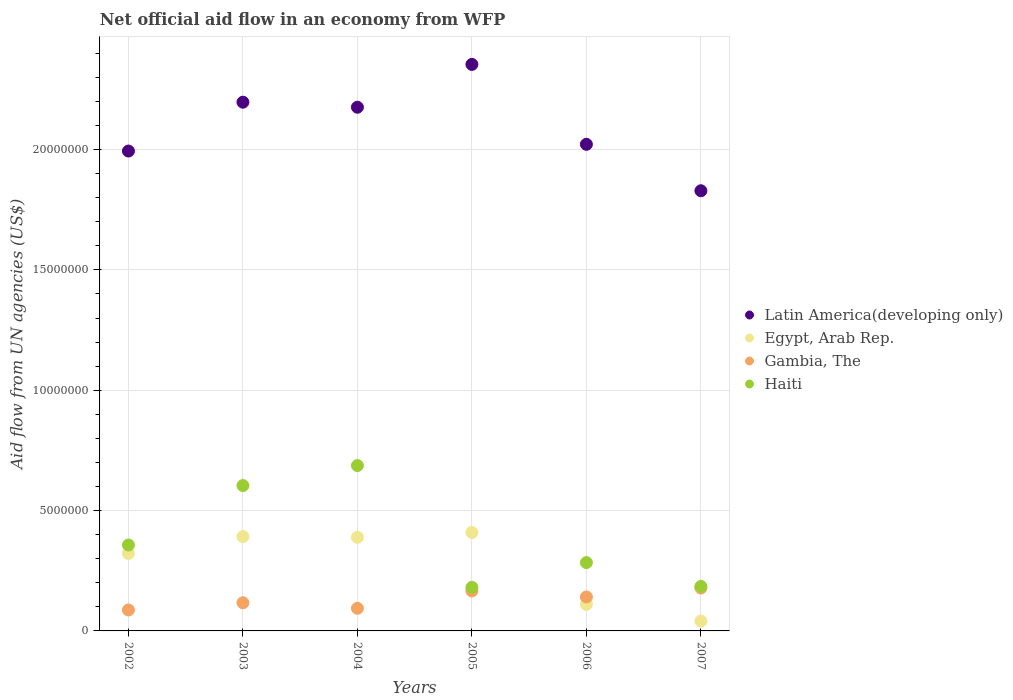How many different coloured dotlines are there?
Give a very brief answer. 4. What is the net official aid flow in Egypt, Arab Rep. in 2007?
Your answer should be compact. 4.10e+05. Across all years, what is the maximum net official aid flow in Gambia, The?
Offer a terse response. 1.78e+06. Across all years, what is the minimum net official aid flow in Egypt, Arab Rep.?
Your response must be concise. 4.10e+05. In which year was the net official aid flow in Latin America(developing only) maximum?
Provide a succinct answer. 2005. What is the total net official aid flow in Latin America(developing only) in the graph?
Your response must be concise. 1.26e+08. What is the difference between the net official aid flow in Egypt, Arab Rep. in 2002 and that in 2004?
Give a very brief answer. -6.70e+05. What is the difference between the net official aid flow in Latin America(developing only) in 2006 and the net official aid flow in Egypt, Arab Rep. in 2005?
Offer a terse response. 1.61e+07. What is the average net official aid flow in Latin America(developing only) per year?
Ensure brevity in your answer.  2.10e+07. In the year 2003, what is the difference between the net official aid flow in Egypt, Arab Rep. and net official aid flow in Latin America(developing only)?
Make the answer very short. -1.80e+07. What is the ratio of the net official aid flow in Haiti in 2003 to that in 2005?
Give a very brief answer. 3.34. Is the net official aid flow in Egypt, Arab Rep. in 2003 less than that in 2004?
Keep it short and to the point. No. Is the difference between the net official aid flow in Egypt, Arab Rep. in 2004 and 2007 greater than the difference between the net official aid flow in Latin America(developing only) in 2004 and 2007?
Your response must be concise. Yes. What is the difference between the highest and the second highest net official aid flow in Latin America(developing only)?
Offer a terse response. 1.57e+06. What is the difference between the highest and the lowest net official aid flow in Gambia, The?
Your answer should be compact. 9.10e+05. Is it the case that in every year, the sum of the net official aid flow in Gambia, The and net official aid flow in Egypt, Arab Rep.  is greater than the net official aid flow in Latin America(developing only)?
Offer a terse response. No. Is the net official aid flow in Egypt, Arab Rep. strictly greater than the net official aid flow in Latin America(developing only) over the years?
Give a very brief answer. No. How many dotlines are there?
Your answer should be compact. 4. How many legend labels are there?
Provide a succinct answer. 4. How are the legend labels stacked?
Provide a succinct answer. Vertical. What is the title of the graph?
Your response must be concise. Net official aid flow in an economy from WFP. Does "South Asia" appear as one of the legend labels in the graph?
Your answer should be compact. No. What is the label or title of the X-axis?
Provide a succinct answer. Years. What is the label or title of the Y-axis?
Provide a succinct answer. Aid flow from UN agencies (US$). What is the Aid flow from UN agencies (US$) in Latin America(developing only) in 2002?
Provide a short and direct response. 1.99e+07. What is the Aid flow from UN agencies (US$) in Egypt, Arab Rep. in 2002?
Your response must be concise. 3.22e+06. What is the Aid flow from UN agencies (US$) in Gambia, The in 2002?
Provide a succinct answer. 8.70e+05. What is the Aid flow from UN agencies (US$) in Haiti in 2002?
Your answer should be compact. 3.57e+06. What is the Aid flow from UN agencies (US$) of Latin America(developing only) in 2003?
Ensure brevity in your answer.  2.20e+07. What is the Aid flow from UN agencies (US$) in Egypt, Arab Rep. in 2003?
Your answer should be compact. 3.92e+06. What is the Aid flow from UN agencies (US$) in Gambia, The in 2003?
Give a very brief answer. 1.17e+06. What is the Aid flow from UN agencies (US$) in Haiti in 2003?
Ensure brevity in your answer.  6.04e+06. What is the Aid flow from UN agencies (US$) in Latin America(developing only) in 2004?
Give a very brief answer. 2.18e+07. What is the Aid flow from UN agencies (US$) in Egypt, Arab Rep. in 2004?
Your answer should be very brief. 3.89e+06. What is the Aid flow from UN agencies (US$) in Gambia, The in 2004?
Give a very brief answer. 9.40e+05. What is the Aid flow from UN agencies (US$) in Haiti in 2004?
Your response must be concise. 6.87e+06. What is the Aid flow from UN agencies (US$) in Latin America(developing only) in 2005?
Your answer should be compact. 2.35e+07. What is the Aid flow from UN agencies (US$) in Egypt, Arab Rep. in 2005?
Your answer should be very brief. 4.09e+06. What is the Aid flow from UN agencies (US$) of Gambia, The in 2005?
Your answer should be compact. 1.66e+06. What is the Aid flow from UN agencies (US$) in Haiti in 2005?
Give a very brief answer. 1.81e+06. What is the Aid flow from UN agencies (US$) of Latin America(developing only) in 2006?
Your response must be concise. 2.02e+07. What is the Aid flow from UN agencies (US$) of Egypt, Arab Rep. in 2006?
Provide a short and direct response. 1.10e+06. What is the Aid flow from UN agencies (US$) in Gambia, The in 2006?
Offer a terse response. 1.41e+06. What is the Aid flow from UN agencies (US$) of Haiti in 2006?
Provide a succinct answer. 2.84e+06. What is the Aid flow from UN agencies (US$) in Latin America(developing only) in 2007?
Give a very brief answer. 1.83e+07. What is the Aid flow from UN agencies (US$) in Gambia, The in 2007?
Give a very brief answer. 1.78e+06. What is the Aid flow from UN agencies (US$) in Haiti in 2007?
Make the answer very short. 1.85e+06. Across all years, what is the maximum Aid flow from UN agencies (US$) in Latin America(developing only)?
Keep it short and to the point. 2.35e+07. Across all years, what is the maximum Aid flow from UN agencies (US$) of Egypt, Arab Rep.?
Make the answer very short. 4.09e+06. Across all years, what is the maximum Aid flow from UN agencies (US$) in Gambia, The?
Provide a succinct answer. 1.78e+06. Across all years, what is the maximum Aid flow from UN agencies (US$) of Haiti?
Provide a succinct answer. 6.87e+06. Across all years, what is the minimum Aid flow from UN agencies (US$) of Latin America(developing only)?
Provide a short and direct response. 1.83e+07. Across all years, what is the minimum Aid flow from UN agencies (US$) of Egypt, Arab Rep.?
Ensure brevity in your answer.  4.10e+05. Across all years, what is the minimum Aid flow from UN agencies (US$) in Gambia, The?
Your response must be concise. 8.70e+05. Across all years, what is the minimum Aid flow from UN agencies (US$) in Haiti?
Your response must be concise. 1.81e+06. What is the total Aid flow from UN agencies (US$) of Latin America(developing only) in the graph?
Offer a terse response. 1.26e+08. What is the total Aid flow from UN agencies (US$) of Egypt, Arab Rep. in the graph?
Ensure brevity in your answer.  1.66e+07. What is the total Aid flow from UN agencies (US$) in Gambia, The in the graph?
Provide a succinct answer. 7.83e+06. What is the total Aid flow from UN agencies (US$) of Haiti in the graph?
Your answer should be compact. 2.30e+07. What is the difference between the Aid flow from UN agencies (US$) in Latin America(developing only) in 2002 and that in 2003?
Provide a succinct answer. -2.03e+06. What is the difference between the Aid flow from UN agencies (US$) in Egypt, Arab Rep. in 2002 and that in 2003?
Provide a short and direct response. -7.00e+05. What is the difference between the Aid flow from UN agencies (US$) in Gambia, The in 2002 and that in 2003?
Your answer should be very brief. -3.00e+05. What is the difference between the Aid flow from UN agencies (US$) in Haiti in 2002 and that in 2003?
Keep it short and to the point. -2.47e+06. What is the difference between the Aid flow from UN agencies (US$) of Latin America(developing only) in 2002 and that in 2004?
Give a very brief answer. -1.82e+06. What is the difference between the Aid flow from UN agencies (US$) of Egypt, Arab Rep. in 2002 and that in 2004?
Your answer should be very brief. -6.70e+05. What is the difference between the Aid flow from UN agencies (US$) in Gambia, The in 2002 and that in 2004?
Ensure brevity in your answer.  -7.00e+04. What is the difference between the Aid flow from UN agencies (US$) in Haiti in 2002 and that in 2004?
Your answer should be compact. -3.30e+06. What is the difference between the Aid flow from UN agencies (US$) of Latin America(developing only) in 2002 and that in 2005?
Make the answer very short. -3.60e+06. What is the difference between the Aid flow from UN agencies (US$) in Egypt, Arab Rep. in 2002 and that in 2005?
Offer a very short reply. -8.70e+05. What is the difference between the Aid flow from UN agencies (US$) of Gambia, The in 2002 and that in 2005?
Provide a succinct answer. -7.90e+05. What is the difference between the Aid flow from UN agencies (US$) in Haiti in 2002 and that in 2005?
Offer a very short reply. 1.76e+06. What is the difference between the Aid flow from UN agencies (US$) of Latin America(developing only) in 2002 and that in 2006?
Your answer should be compact. -2.80e+05. What is the difference between the Aid flow from UN agencies (US$) in Egypt, Arab Rep. in 2002 and that in 2006?
Provide a short and direct response. 2.12e+06. What is the difference between the Aid flow from UN agencies (US$) in Gambia, The in 2002 and that in 2006?
Your answer should be very brief. -5.40e+05. What is the difference between the Aid flow from UN agencies (US$) in Haiti in 2002 and that in 2006?
Your answer should be compact. 7.30e+05. What is the difference between the Aid flow from UN agencies (US$) in Latin America(developing only) in 2002 and that in 2007?
Keep it short and to the point. 1.65e+06. What is the difference between the Aid flow from UN agencies (US$) of Egypt, Arab Rep. in 2002 and that in 2007?
Your answer should be compact. 2.81e+06. What is the difference between the Aid flow from UN agencies (US$) of Gambia, The in 2002 and that in 2007?
Keep it short and to the point. -9.10e+05. What is the difference between the Aid flow from UN agencies (US$) of Haiti in 2002 and that in 2007?
Your answer should be compact. 1.72e+06. What is the difference between the Aid flow from UN agencies (US$) in Latin America(developing only) in 2003 and that in 2004?
Your answer should be compact. 2.10e+05. What is the difference between the Aid flow from UN agencies (US$) of Haiti in 2003 and that in 2004?
Ensure brevity in your answer.  -8.30e+05. What is the difference between the Aid flow from UN agencies (US$) in Latin America(developing only) in 2003 and that in 2005?
Give a very brief answer. -1.57e+06. What is the difference between the Aid flow from UN agencies (US$) of Egypt, Arab Rep. in 2003 and that in 2005?
Make the answer very short. -1.70e+05. What is the difference between the Aid flow from UN agencies (US$) in Gambia, The in 2003 and that in 2005?
Keep it short and to the point. -4.90e+05. What is the difference between the Aid flow from UN agencies (US$) of Haiti in 2003 and that in 2005?
Your answer should be very brief. 4.23e+06. What is the difference between the Aid flow from UN agencies (US$) in Latin America(developing only) in 2003 and that in 2006?
Ensure brevity in your answer.  1.75e+06. What is the difference between the Aid flow from UN agencies (US$) in Egypt, Arab Rep. in 2003 and that in 2006?
Your answer should be compact. 2.82e+06. What is the difference between the Aid flow from UN agencies (US$) of Gambia, The in 2003 and that in 2006?
Your answer should be compact. -2.40e+05. What is the difference between the Aid flow from UN agencies (US$) of Haiti in 2003 and that in 2006?
Provide a succinct answer. 3.20e+06. What is the difference between the Aid flow from UN agencies (US$) of Latin America(developing only) in 2003 and that in 2007?
Keep it short and to the point. 3.68e+06. What is the difference between the Aid flow from UN agencies (US$) of Egypt, Arab Rep. in 2003 and that in 2007?
Provide a succinct answer. 3.51e+06. What is the difference between the Aid flow from UN agencies (US$) of Gambia, The in 2003 and that in 2007?
Your response must be concise. -6.10e+05. What is the difference between the Aid flow from UN agencies (US$) in Haiti in 2003 and that in 2007?
Your response must be concise. 4.19e+06. What is the difference between the Aid flow from UN agencies (US$) in Latin America(developing only) in 2004 and that in 2005?
Keep it short and to the point. -1.78e+06. What is the difference between the Aid flow from UN agencies (US$) of Gambia, The in 2004 and that in 2005?
Give a very brief answer. -7.20e+05. What is the difference between the Aid flow from UN agencies (US$) in Haiti in 2004 and that in 2005?
Your answer should be very brief. 5.06e+06. What is the difference between the Aid flow from UN agencies (US$) of Latin America(developing only) in 2004 and that in 2006?
Give a very brief answer. 1.54e+06. What is the difference between the Aid flow from UN agencies (US$) of Egypt, Arab Rep. in 2004 and that in 2006?
Your answer should be very brief. 2.79e+06. What is the difference between the Aid flow from UN agencies (US$) of Gambia, The in 2004 and that in 2006?
Keep it short and to the point. -4.70e+05. What is the difference between the Aid flow from UN agencies (US$) of Haiti in 2004 and that in 2006?
Your answer should be very brief. 4.03e+06. What is the difference between the Aid flow from UN agencies (US$) in Latin America(developing only) in 2004 and that in 2007?
Your response must be concise. 3.47e+06. What is the difference between the Aid flow from UN agencies (US$) in Egypt, Arab Rep. in 2004 and that in 2007?
Give a very brief answer. 3.48e+06. What is the difference between the Aid flow from UN agencies (US$) of Gambia, The in 2004 and that in 2007?
Make the answer very short. -8.40e+05. What is the difference between the Aid flow from UN agencies (US$) in Haiti in 2004 and that in 2007?
Give a very brief answer. 5.02e+06. What is the difference between the Aid flow from UN agencies (US$) of Latin America(developing only) in 2005 and that in 2006?
Provide a succinct answer. 3.32e+06. What is the difference between the Aid flow from UN agencies (US$) in Egypt, Arab Rep. in 2005 and that in 2006?
Give a very brief answer. 2.99e+06. What is the difference between the Aid flow from UN agencies (US$) in Gambia, The in 2005 and that in 2006?
Keep it short and to the point. 2.50e+05. What is the difference between the Aid flow from UN agencies (US$) of Haiti in 2005 and that in 2006?
Give a very brief answer. -1.03e+06. What is the difference between the Aid flow from UN agencies (US$) of Latin America(developing only) in 2005 and that in 2007?
Provide a succinct answer. 5.25e+06. What is the difference between the Aid flow from UN agencies (US$) in Egypt, Arab Rep. in 2005 and that in 2007?
Your answer should be compact. 3.68e+06. What is the difference between the Aid flow from UN agencies (US$) in Haiti in 2005 and that in 2007?
Ensure brevity in your answer.  -4.00e+04. What is the difference between the Aid flow from UN agencies (US$) of Latin America(developing only) in 2006 and that in 2007?
Keep it short and to the point. 1.93e+06. What is the difference between the Aid flow from UN agencies (US$) of Egypt, Arab Rep. in 2006 and that in 2007?
Make the answer very short. 6.90e+05. What is the difference between the Aid flow from UN agencies (US$) of Gambia, The in 2006 and that in 2007?
Your answer should be compact. -3.70e+05. What is the difference between the Aid flow from UN agencies (US$) of Haiti in 2006 and that in 2007?
Keep it short and to the point. 9.90e+05. What is the difference between the Aid flow from UN agencies (US$) in Latin America(developing only) in 2002 and the Aid flow from UN agencies (US$) in Egypt, Arab Rep. in 2003?
Your response must be concise. 1.60e+07. What is the difference between the Aid flow from UN agencies (US$) of Latin America(developing only) in 2002 and the Aid flow from UN agencies (US$) of Gambia, The in 2003?
Your response must be concise. 1.88e+07. What is the difference between the Aid flow from UN agencies (US$) of Latin America(developing only) in 2002 and the Aid flow from UN agencies (US$) of Haiti in 2003?
Offer a very short reply. 1.39e+07. What is the difference between the Aid flow from UN agencies (US$) in Egypt, Arab Rep. in 2002 and the Aid flow from UN agencies (US$) in Gambia, The in 2003?
Your answer should be very brief. 2.05e+06. What is the difference between the Aid flow from UN agencies (US$) of Egypt, Arab Rep. in 2002 and the Aid flow from UN agencies (US$) of Haiti in 2003?
Provide a succinct answer. -2.82e+06. What is the difference between the Aid flow from UN agencies (US$) in Gambia, The in 2002 and the Aid flow from UN agencies (US$) in Haiti in 2003?
Give a very brief answer. -5.17e+06. What is the difference between the Aid flow from UN agencies (US$) of Latin America(developing only) in 2002 and the Aid flow from UN agencies (US$) of Egypt, Arab Rep. in 2004?
Give a very brief answer. 1.60e+07. What is the difference between the Aid flow from UN agencies (US$) in Latin America(developing only) in 2002 and the Aid flow from UN agencies (US$) in Gambia, The in 2004?
Offer a very short reply. 1.90e+07. What is the difference between the Aid flow from UN agencies (US$) in Latin America(developing only) in 2002 and the Aid flow from UN agencies (US$) in Haiti in 2004?
Your answer should be very brief. 1.31e+07. What is the difference between the Aid flow from UN agencies (US$) in Egypt, Arab Rep. in 2002 and the Aid flow from UN agencies (US$) in Gambia, The in 2004?
Give a very brief answer. 2.28e+06. What is the difference between the Aid flow from UN agencies (US$) of Egypt, Arab Rep. in 2002 and the Aid flow from UN agencies (US$) of Haiti in 2004?
Offer a terse response. -3.65e+06. What is the difference between the Aid flow from UN agencies (US$) of Gambia, The in 2002 and the Aid flow from UN agencies (US$) of Haiti in 2004?
Give a very brief answer. -6.00e+06. What is the difference between the Aid flow from UN agencies (US$) of Latin America(developing only) in 2002 and the Aid flow from UN agencies (US$) of Egypt, Arab Rep. in 2005?
Offer a very short reply. 1.58e+07. What is the difference between the Aid flow from UN agencies (US$) of Latin America(developing only) in 2002 and the Aid flow from UN agencies (US$) of Gambia, The in 2005?
Your answer should be compact. 1.83e+07. What is the difference between the Aid flow from UN agencies (US$) in Latin America(developing only) in 2002 and the Aid flow from UN agencies (US$) in Haiti in 2005?
Your answer should be compact. 1.81e+07. What is the difference between the Aid flow from UN agencies (US$) in Egypt, Arab Rep. in 2002 and the Aid flow from UN agencies (US$) in Gambia, The in 2005?
Keep it short and to the point. 1.56e+06. What is the difference between the Aid flow from UN agencies (US$) of Egypt, Arab Rep. in 2002 and the Aid flow from UN agencies (US$) of Haiti in 2005?
Ensure brevity in your answer.  1.41e+06. What is the difference between the Aid flow from UN agencies (US$) of Gambia, The in 2002 and the Aid flow from UN agencies (US$) of Haiti in 2005?
Your answer should be compact. -9.40e+05. What is the difference between the Aid flow from UN agencies (US$) of Latin America(developing only) in 2002 and the Aid flow from UN agencies (US$) of Egypt, Arab Rep. in 2006?
Your answer should be very brief. 1.88e+07. What is the difference between the Aid flow from UN agencies (US$) of Latin America(developing only) in 2002 and the Aid flow from UN agencies (US$) of Gambia, The in 2006?
Provide a short and direct response. 1.85e+07. What is the difference between the Aid flow from UN agencies (US$) in Latin America(developing only) in 2002 and the Aid flow from UN agencies (US$) in Haiti in 2006?
Provide a short and direct response. 1.71e+07. What is the difference between the Aid flow from UN agencies (US$) in Egypt, Arab Rep. in 2002 and the Aid flow from UN agencies (US$) in Gambia, The in 2006?
Provide a succinct answer. 1.81e+06. What is the difference between the Aid flow from UN agencies (US$) of Egypt, Arab Rep. in 2002 and the Aid flow from UN agencies (US$) of Haiti in 2006?
Your answer should be compact. 3.80e+05. What is the difference between the Aid flow from UN agencies (US$) of Gambia, The in 2002 and the Aid flow from UN agencies (US$) of Haiti in 2006?
Give a very brief answer. -1.97e+06. What is the difference between the Aid flow from UN agencies (US$) of Latin America(developing only) in 2002 and the Aid flow from UN agencies (US$) of Egypt, Arab Rep. in 2007?
Your answer should be compact. 1.95e+07. What is the difference between the Aid flow from UN agencies (US$) of Latin America(developing only) in 2002 and the Aid flow from UN agencies (US$) of Gambia, The in 2007?
Provide a succinct answer. 1.82e+07. What is the difference between the Aid flow from UN agencies (US$) of Latin America(developing only) in 2002 and the Aid flow from UN agencies (US$) of Haiti in 2007?
Your response must be concise. 1.81e+07. What is the difference between the Aid flow from UN agencies (US$) of Egypt, Arab Rep. in 2002 and the Aid flow from UN agencies (US$) of Gambia, The in 2007?
Your response must be concise. 1.44e+06. What is the difference between the Aid flow from UN agencies (US$) in Egypt, Arab Rep. in 2002 and the Aid flow from UN agencies (US$) in Haiti in 2007?
Offer a very short reply. 1.37e+06. What is the difference between the Aid flow from UN agencies (US$) of Gambia, The in 2002 and the Aid flow from UN agencies (US$) of Haiti in 2007?
Your answer should be compact. -9.80e+05. What is the difference between the Aid flow from UN agencies (US$) in Latin America(developing only) in 2003 and the Aid flow from UN agencies (US$) in Egypt, Arab Rep. in 2004?
Offer a terse response. 1.81e+07. What is the difference between the Aid flow from UN agencies (US$) in Latin America(developing only) in 2003 and the Aid flow from UN agencies (US$) in Gambia, The in 2004?
Ensure brevity in your answer.  2.10e+07. What is the difference between the Aid flow from UN agencies (US$) in Latin America(developing only) in 2003 and the Aid flow from UN agencies (US$) in Haiti in 2004?
Provide a short and direct response. 1.51e+07. What is the difference between the Aid flow from UN agencies (US$) of Egypt, Arab Rep. in 2003 and the Aid flow from UN agencies (US$) of Gambia, The in 2004?
Your response must be concise. 2.98e+06. What is the difference between the Aid flow from UN agencies (US$) of Egypt, Arab Rep. in 2003 and the Aid flow from UN agencies (US$) of Haiti in 2004?
Provide a succinct answer. -2.95e+06. What is the difference between the Aid flow from UN agencies (US$) in Gambia, The in 2003 and the Aid flow from UN agencies (US$) in Haiti in 2004?
Your response must be concise. -5.70e+06. What is the difference between the Aid flow from UN agencies (US$) in Latin America(developing only) in 2003 and the Aid flow from UN agencies (US$) in Egypt, Arab Rep. in 2005?
Your answer should be very brief. 1.79e+07. What is the difference between the Aid flow from UN agencies (US$) in Latin America(developing only) in 2003 and the Aid flow from UN agencies (US$) in Gambia, The in 2005?
Give a very brief answer. 2.03e+07. What is the difference between the Aid flow from UN agencies (US$) in Latin America(developing only) in 2003 and the Aid flow from UN agencies (US$) in Haiti in 2005?
Make the answer very short. 2.02e+07. What is the difference between the Aid flow from UN agencies (US$) in Egypt, Arab Rep. in 2003 and the Aid flow from UN agencies (US$) in Gambia, The in 2005?
Your answer should be compact. 2.26e+06. What is the difference between the Aid flow from UN agencies (US$) in Egypt, Arab Rep. in 2003 and the Aid flow from UN agencies (US$) in Haiti in 2005?
Provide a succinct answer. 2.11e+06. What is the difference between the Aid flow from UN agencies (US$) in Gambia, The in 2003 and the Aid flow from UN agencies (US$) in Haiti in 2005?
Make the answer very short. -6.40e+05. What is the difference between the Aid flow from UN agencies (US$) in Latin America(developing only) in 2003 and the Aid flow from UN agencies (US$) in Egypt, Arab Rep. in 2006?
Offer a terse response. 2.09e+07. What is the difference between the Aid flow from UN agencies (US$) in Latin America(developing only) in 2003 and the Aid flow from UN agencies (US$) in Gambia, The in 2006?
Provide a succinct answer. 2.06e+07. What is the difference between the Aid flow from UN agencies (US$) in Latin America(developing only) in 2003 and the Aid flow from UN agencies (US$) in Haiti in 2006?
Keep it short and to the point. 1.91e+07. What is the difference between the Aid flow from UN agencies (US$) in Egypt, Arab Rep. in 2003 and the Aid flow from UN agencies (US$) in Gambia, The in 2006?
Ensure brevity in your answer.  2.51e+06. What is the difference between the Aid flow from UN agencies (US$) in Egypt, Arab Rep. in 2003 and the Aid flow from UN agencies (US$) in Haiti in 2006?
Ensure brevity in your answer.  1.08e+06. What is the difference between the Aid flow from UN agencies (US$) in Gambia, The in 2003 and the Aid flow from UN agencies (US$) in Haiti in 2006?
Keep it short and to the point. -1.67e+06. What is the difference between the Aid flow from UN agencies (US$) in Latin America(developing only) in 2003 and the Aid flow from UN agencies (US$) in Egypt, Arab Rep. in 2007?
Ensure brevity in your answer.  2.16e+07. What is the difference between the Aid flow from UN agencies (US$) of Latin America(developing only) in 2003 and the Aid flow from UN agencies (US$) of Gambia, The in 2007?
Keep it short and to the point. 2.02e+07. What is the difference between the Aid flow from UN agencies (US$) in Latin America(developing only) in 2003 and the Aid flow from UN agencies (US$) in Haiti in 2007?
Give a very brief answer. 2.01e+07. What is the difference between the Aid flow from UN agencies (US$) of Egypt, Arab Rep. in 2003 and the Aid flow from UN agencies (US$) of Gambia, The in 2007?
Your answer should be very brief. 2.14e+06. What is the difference between the Aid flow from UN agencies (US$) in Egypt, Arab Rep. in 2003 and the Aid flow from UN agencies (US$) in Haiti in 2007?
Offer a terse response. 2.07e+06. What is the difference between the Aid flow from UN agencies (US$) of Gambia, The in 2003 and the Aid flow from UN agencies (US$) of Haiti in 2007?
Provide a succinct answer. -6.80e+05. What is the difference between the Aid flow from UN agencies (US$) of Latin America(developing only) in 2004 and the Aid flow from UN agencies (US$) of Egypt, Arab Rep. in 2005?
Your response must be concise. 1.77e+07. What is the difference between the Aid flow from UN agencies (US$) of Latin America(developing only) in 2004 and the Aid flow from UN agencies (US$) of Gambia, The in 2005?
Your answer should be compact. 2.01e+07. What is the difference between the Aid flow from UN agencies (US$) of Latin America(developing only) in 2004 and the Aid flow from UN agencies (US$) of Haiti in 2005?
Your answer should be very brief. 2.00e+07. What is the difference between the Aid flow from UN agencies (US$) in Egypt, Arab Rep. in 2004 and the Aid flow from UN agencies (US$) in Gambia, The in 2005?
Your response must be concise. 2.23e+06. What is the difference between the Aid flow from UN agencies (US$) of Egypt, Arab Rep. in 2004 and the Aid flow from UN agencies (US$) of Haiti in 2005?
Offer a terse response. 2.08e+06. What is the difference between the Aid flow from UN agencies (US$) of Gambia, The in 2004 and the Aid flow from UN agencies (US$) of Haiti in 2005?
Your answer should be compact. -8.70e+05. What is the difference between the Aid flow from UN agencies (US$) in Latin America(developing only) in 2004 and the Aid flow from UN agencies (US$) in Egypt, Arab Rep. in 2006?
Your answer should be very brief. 2.07e+07. What is the difference between the Aid flow from UN agencies (US$) in Latin America(developing only) in 2004 and the Aid flow from UN agencies (US$) in Gambia, The in 2006?
Your response must be concise. 2.04e+07. What is the difference between the Aid flow from UN agencies (US$) of Latin America(developing only) in 2004 and the Aid flow from UN agencies (US$) of Haiti in 2006?
Provide a short and direct response. 1.89e+07. What is the difference between the Aid flow from UN agencies (US$) in Egypt, Arab Rep. in 2004 and the Aid flow from UN agencies (US$) in Gambia, The in 2006?
Offer a terse response. 2.48e+06. What is the difference between the Aid flow from UN agencies (US$) in Egypt, Arab Rep. in 2004 and the Aid flow from UN agencies (US$) in Haiti in 2006?
Ensure brevity in your answer.  1.05e+06. What is the difference between the Aid flow from UN agencies (US$) in Gambia, The in 2004 and the Aid flow from UN agencies (US$) in Haiti in 2006?
Provide a short and direct response. -1.90e+06. What is the difference between the Aid flow from UN agencies (US$) of Latin America(developing only) in 2004 and the Aid flow from UN agencies (US$) of Egypt, Arab Rep. in 2007?
Your response must be concise. 2.14e+07. What is the difference between the Aid flow from UN agencies (US$) in Latin America(developing only) in 2004 and the Aid flow from UN agencies (US$) in Gambia, The in 2007?
Provide a succinct answer. 2.00e+07. What is the difference between the Aid flow from UN agencies (US$) of Latin America(developing only) in 2004 and the Aid flow from UN agencies (US$) of Haiti in 2007?
Offer a terse response. 1.99e+07. What is the difference between the Aid flow from UN agencies (US$) in Egypt, Arab Rep. in 2004 and the Aid flow from UN agencies (US$) in Gambia, The in 2007?
Your answer should be very brief. 2.11e+06. What is the difference between the Aid flow from UN agencies (US$) in Egypt, Arab Rep. in 2004 and the Aid flow from UN agencies (US$) in Haiti in 2007?
Offer a terse response. 2.04e+06. What is the difference between the Aid flow from UN agencies (US$) of Gambia, The in 2004 and the Aid flow from UN agencies (US$) of Haiti in 2007?
Offer a terse response. -9.10e+05. What is the difference between the Aid flow from UN agencies (US$) in Latin America(developing only) in 2005 and the Aid flow from UN agencies (US$) in Egypt, Arab Rep. in 2006?
Offer a very short reply. 2.24e+07. What is the difference between the Aid flow from UN agencies (US$) of Latin America(developing only) in 2005 and the Aid flow from UN agencies (US$) of Gambia, The in 2006?
Your answer should be compact. 2.21e+07. What is the difference between the Aid flow from UN agencies (US$) of Latin America(developing only) in 2005 and the Aid flow from UN agencies (US$) of Haiti in 2006?
Your response must be concise. 2.07e+07. What is the difference between the Aid flow from UN agencies (US$) of Egypt, Arab Rep. in 2005 and the Aid flow from UN agencies (US$) of Gambia, The in 2006?
Keep it short and to the point. 2.68e+06. What is the difference between the Aid flow from UN agencies (US$) of Egypt, Arab Rep. in 2005 and the Aid flow from UN agencies (US$) of Haiti in 2006?
Provide a succinct answer. 1.25e+06. What is the difference between the Aid flow from UN agencies (US$) of Gambia, The in 2005 and the Aid flow from UN agencies (US$) of Haiti in 2006?
Offer a very short reply. -1.18e+06. What is the difference between the Aid flow from UN agencies (US$) of Latin America(developing only) in 2005 and the Aid flow from UN agencies (US$) of Egypt, Arab Rep. in 2007?
Provide a short and direct response. 2.31e+07. What is the difference between the Aid flow from UN agencies (US$) in Latin America(developing only) in 2005 and the Aid flow from UN agencies (US$) in Gambia, The in 2007?
Provide a succinct answer. 2.18e+07. What is the difference between the Aid flow from UN agencies (US$) of Latin America(developing only) in 2005 and the Aid flow from UN agencies (US$) of Haiti in 2007?
Your answer should be very brief. 2.17e+07. What is the difference between the Aid flow from UN agencies (US$) in Egypt, Arab Rep. in 2005 and the Aid flow from UN agencies (US$) in Gambia, The in 2007?
Your answer should be very brief. 2.31e+06. What is the difference between the Aid flow from UN agencies (US$) of Egypt, Arab Rep. in 2005 and the Aid flow from UN agencies (US$) of Haiti in 2007?
Offer a terse response. 2.24e+06. What is the difference between the Aid flow from UN agencies (US$) in Gambia, The in 2005 and the Aid flow from UN agencies (US$) in Haiti in 2007?
Give a very brief answer. -1.90e+05. What is the difference between the Aid flow from UN agencies (US$) in Latin America(developing only) in 2006 and the Aid flow from UN agencies (US$) in Egypt, Arab Rep. in 2007?
Your answer should be very brief. 1.98e+07. What is the difference between the Aid flow from UN agencies (US$) of Latin America(developing only) in 2006 and the Aid flow from UN agencies (US$) of Gambia, The in 2007?
Keep it short and to the point. 1.84e+07. What is the difference between the Aid flow from UN agencies (US$) of Latin America(developing only) in 2006 and the Aid flow from UN agencies (US$) of Haiti in 2007?
Offer a terse response. 1.84e+07. What is the difference between the Aid flow from UN agencies (US$) in Egypt, Arab Rep. in 2006 and the Aid flow from UN agencies (US$) in Gambia, The in 2007?
Ensure brevity in your answer.  -6.80e+05. What is the difference between the Aid flow from UN agencies (US$) in Egypt, Arab Rep. in 2006 and the Aid flow from UN agencies (US$) in Haiti in 2007?
Offer a terse response. -7.50e+05. What is the difference between the Aid flow from UN agencies (US$) of Gambia, The in 2006 and the Aid flow from UN agencies (US$) of Haiti in 2007?
Your response must be concise. -4.40e+05. What is the average Aid flow from UN agencies (US$) in Latin America(developing only) per year?
Offer a very short reply. 2.10e+07. What is the average Aid flow from UN agencies (US$) of Egypt, Arab Rep. per year?
Your answer should be very brief. 2.77e+06. What is the average Aid flow from UN agencies (US$) of Gambia, The per year?
Offer a very short reply. 1.30e+06. What is the average Aid flow from UN agencies (US$) in Haiti per year?
Your response must be concise. 3.83e+06. In the year 2002, what is the difference between the Aid flow from UN agencies (US$) of Latin America(developing only) and Aid flow from UN agencies (US$) of Egypt, Arab Rep.?
Keep it short and to the point. 1.67e+07. In the year 2002, what is the difference between the Aid flow from UN agencies (US$) in Latin America(developing only) and Aid flow from UN agencies (US$) in Gambia, The?
Offer a terse response. 1.91e+07. In the year 2002, what is the difference between the Aid flow from UN agencies (US$) in Latin America(developing only) and Aid flow from UN agencies (US$) in Haiti?
Your answer should be very brief. 1.64e+07. In the year 2002, what is the difference between the Aid flow from UN agencies (US$) of Egypt, Arab Rep. and Aid flow from UN agencies (US$) of Gambia, The?
Make the answer very short. 2.35e+06. In the year 2002, what is the difference between the Aid flow from UN agencies (US$) in Egypt, Arab Rep. and Aid flow from UN agencies (US$) in Haiti?
Your answer should be compact. -3.50e+05. In the year 2002, what is the difference between the Aid flow from UN agencies (US$) of Gambia, The and Aid flow from UN agencies (US$) of Haiti?
Make the answer very short. -2.70e+06. In the year 2003, what is the difference between the Aid flow from UN agencies (US$) in Latin America(developing only) and Aid flow from UN agencies (US$) in Egypt, Arab Rep.?
Your answer should be very brief. 1.80e+07. In the year 2003, what is the difference between the Aid flow from UN agencies (US$) in Latin America(developing only) and Aid flow from UN agencies (US$) in Gambia, The?
Provide a succinct answer. 2.08e+07. In the year 2003, what is the difference between the Aid flow from UN agencies (US$) in Latin America(developing only) and Aid flow from UN agencies (US$) in Haiti?
Your response must be concise. 1.59e+07. In the year 2003, what is the difference between the Aid flow from UN agencies (US$) of Egypt, Arab Rep. and Aid flow from UN agencies (US$) of Gambia, The?
Ensure brevity in your answer.  2.75e+06. In the year 2003, what is the difference between the Aid flow from UN agencies (US$) in Egypt, Arab Rep. and Aid flow from UN agencies (US$) in Haiti?
Provide a short and direct response. -2.12e+06. In the year 2003, what is the difference between the Aid flow from UN agencies (US$) of Gambia, The and Aid flow from UN agencies (US$) of Haiti?
Offer a very short reply. -4.87e+06. In the year 2004, what is the difference between the Aid flow from UN agencies (US$) of Latin America(developing only) and Aid flow from UN agencies (US$) of Egypt, Arab Rep.?
Ensure brevity in your answer.  1.79e+07. In the year 2004, what is the difference between the Aid flow from UN agencies (US$) of Latin America(developing only) and Aid flow from UN agencies (US$) of Gambia, The?
Your answer should be very brief. 2.08e+07. In the year 2004, what is the difference between the Aid flow from UN agencies (US$) of Latin America(developing only) and Aid flow from UN agencies (US$) of Haiti?
Make the answer very short. 1.49e+07. In the year 2004, what is the difference between the Aid flow from UN agencies (US$) of Egypt, Arab Rep. and Aid flow from UN agencies (US$) of Gambia, The?
Ensure brevity in your answer.  2.95e+06. In the year 2004, what is the difference between the Aid flow from UN agencies (US$) of Egypt, Arab Rep. and Aid flow from UN agencies (US$) of Haiti?
Make the answer very short. -2.98e+06. In the year 2004, what is the difference between the Aid flow from UN agencies (US$) of Gambia, The and Aid flow from UN agencies (US$) of Haiti?
Your answer should be compact. -5.93e+06. In the year 2005, what is the difference between the Aid flow from UN agencies (US$) of Latin America(developing only) and Aid flow from UN agencies (US$) of Egypt, Arab Rep.?
Ensure brevity in your answer.  1.94e+07. In the year 2005, what is the difference between the Aid flow from UN agencies (US$) of Latin America(developing only) and Aid flow from UN agencies (US$) of Gambia, The?
Your answer should be very brief. 2.19e+07. In the year 2005, what is the difference between the Aid flow from UN agencies (US$) of Latin America(developing only) and Aid flow from UN agencies (US$) of Haiti?
Offer a terse response. 2.17e+07. In the year 2005, what is the difference between the Aid flow from UN agencies (US$) of Egypt, Arab Rep. and Aid flow from UN agencies (US$) of Gambia, The?
Provide a short and direct response. 2.43e+06. In the year 2005, what is the difference between the Aid flow from UN agencies (US$) in Egypt, Arab Rep. and Aid flow from UN agencies (US$) in Haiti?
Offer a very short reply. 2.28e+06. In the year 2006, what is the difference between the Aid flow from UN agencies (US$) in Latin America(developing only) and Aid flow from UN agencies (US$) in Egypt, Arab Rep.?
Provide a succinct answer. 1.91e+07. In the year 2006, what is the difference between the Aid flow from UN agencies (US$) in Latin America(developing only) and Aid flow from UN agencies (US$) in Gambia, The?
Provide a short and direct response. 1.88e+07. In the year 2006, what is the difference between the Aid flow from UN agencies (US$) in Latin America(developing only) and Aid flow from UN agencies (US$) in Haiti?
Your response must be concise. 1.74e+07. In the year 2006, what is the difference between the Aid flow from UN agencies (US$) of Egypt, Arab Rep. and Aid flow from UN agencies (US$) of Gambia, The?
Your answer should be very brief. -3.10e+05. In the year 2006, what is the difference between the Aid flow from UN agencies (US$) in Egypt, Arab Rep. and Aid flow from UN agencies (US$) in Haiti?
Keep it short and to the point. -1.74e+06. In the year 2006, what is the difference between the Aid flow from UN agencies (US$) of Gambia, The and Aid flow from UN agencies (US$) of Haiti?
Ensure brevity in your answer.  -1.43e+06. In the year 2007, what is the difference between the Aid flow from UN agencies (US$) in Latin America(developing only) and Aid flow from UN agencies (US$) in Egypt, Arab Rep.?
Your response must be concise. 1.79e+07. In the year 2007, what is the difference between the Aid flow from UN agencies (US$) in Latin America(developing only) and Aid flow from UN agencies (US$) in Gambia, The?
Offer a very short reply. 1.65e+07. In the year 2007, what is the difference between the Aid flow from UN agencies (US$) in Latin America(developing only) and Aid flow from UN agencies (US$) in Haiti?
Provide a succinct answer. 1.64e+07. In the year 2007, what is the difference between the Aid flow from UN agencies (US$) of Egypt, Arab Rep. and Aid flow from UN agencies (US$) of Gambia, The?
Provide a short and direct response. -1.37e+06. In the year 2007, what is the difference between the Aid flow from UN agencies (US$) in Egypt, Arab Rep. and Aid flow from UN agencies (US$) in Haiti?
Ensure brevity in your answer.  -1.44e+06. In the year 2007, what is the difference between the Aid flow from UN agencies (US$) of Gambia, The and Aid flow from UN agencies (US$) of Haiti?
Your answer should be very brief. -7.00e+04. What is the ratio of the Aid flow from UN agencies (US$) in Latin America(developing only) in 2002 to that in 2003?
Make the answer very short. 0.91. What is the ratio of the Aid flow from UN agencies (US$) of Egypt, Arab Rep. in 2002 to that in 2003?
Provide a succinct answer. 0.82. What is the ratio of the Aid flow from UN agencies (US$) in Gambia, The in 2002 to that in 2003?
Keep it short and to the point. 0.74. What is the ratio of the Aid flow from UN agencies (US$) of Haiti in 2002 to that in 2003?
Offer a very short reply. 0.59. What is the ratio of the Aid flow from UN agencies (US$) in Latin America(developing only) in 2002 to that in 2004?
Keep it short and to the point. 0.92. What is the ratio of the Aid flow from UN agencies (US$) of Egypt, Arab Rep. in 2002 to that in 2004?
Your answer should be compact. 0.83. What is the ratio of the Aid flow from UN agencies (US$) of Gambia, The in 2002 to that in 2004?
Your answer should be compact. 0.93. What is the ratio of the Aid flow from UN agencies (US$) of Haiti in 2002 to that in 2004?
Provide a succinct answer. 0.52. What is the ratio of the Aid flow from UN agencies (US$) of Latin America(developing only) in 2002 to that in 2005?
Make the answer very short. 0.85. What is the ratio of the Aid flow from UN agencies (US$) of Egypt, Arab Rep. in 2002 to that in 2005?
Your answer should be very brief. 0.79. What is the ratio of the Aid flow from UN agencies (US$) of Gambia, The in 2002 to that in 2005?
Ensure brevity in your answer.  0.52. What is the ratio of the Aid flow from UN agencies (US$) of Haiti in 2002 to that in 2005?
Give a very brief answer. 1.97. What is the ratio of the Aid flow from UN agencies (US$) of Latin America(developing only) in 2002 to that in 2006?
Keep it short and to the point. 0.99. What is the ratio of the Aid flow from UN agencies (US$) in Egypt, Arab Rep. in 2002 to that in 2006?
Your response must be concise. 2.93. What is the ratio of the Aid flow from UN agencies (US$) in Gambia, The in 2002 to that in 2006?
Keep it short and to the point. 0.62. What is the ratio of the Aid flow from UN agencies (US$) in Haiti in 2002 to that in 2006?
Offer a very short reply. 1.26. What is the ratio of the Aid flow from UN agencies (US$) in Latin America(developing only) in 2002 to that in 2007?
Give a very brief answer. 1.09. What is the ratio of the Aid flow from UN agencies (US$) of Egypt, Arab Rep. in 2002 to that in 2007?
Offer a terse response. 7.85. What is the ratio of the Aid flow from UN agencies (US$) in Gambia, The in 2002 to that in 2007?
Provide a short and direct response. 0.49. What is the ratio of the Aid flow from UN agencies (US$) in Haiti in 2002 to that in 2007?
Keep it short and to the point. 1.93. What is the ratio of the Aid flow from UN agencies (US$) in Latin America(developing only) in 2003 to that in 2004?
Provide a succinct answer. 1.01. What is the ratio of the Aid flow from UN agencies (US$) of Egypt, Arab Rep. in 2003 to that in 2004?
Offer a terse response. 1.01. What is the ratio of the Aid flow from UN agencies (US$) in Gambia, The in 2003 to that in 2004?
Ensure brevity in your answer.  1.24. What is the ratio of the Aid flow from UN agencies (US$) in Haiti in 2003 to that in 2004?
Keep it short and to the point. 0.88. What is the ratio of the Aid flow from UN agencies (US$) of Latin America(developing only) in 2003 to that in 2005?
Offer a very short reply. 0.93. What is the ratio of the Aid flow from UN agencies (US$) in Egypt, Arab Rep. in 2003 to that in 2005?
Offer a terse response. 0.96. What is the ratio of the Aid flow from UN agencies (US$) of Gambia, The in 2003 to that in 2005?
Make the answer very short. 0.7. What is the ratio of the Aid flow from UN agencies (US$) in Haiti in 2003 to that in 2005?
Your response must be concise. 3.34. What is the ratio of the Aid flow from UN agencies (US$) of Latin America(developing only) in 2003 to that in 2006?
Your answer should be very brief. 1.09. What is the ratio of the Aid flow from UN agencies (US$) in Egypt, Arab Rep. in 2003 to that in 2006?
Offer a terse response. 3.56. What is the ratio of the Aid flow from UN agencies (US$) in Gambia, The in 2003 to that in 2006?
Your response must be concise. 0.83. What is the ratio of the Aid flow from UN agencies (US$) of Haiti in 2003 to that in 2006?
Offer a very short reply. 2.13. What is the ratio of the Aid flow from UN agencies (US$) of Latin America(developing only) in 2003 to that in 2007?
Give a very brief answer. 1.2. What is the ratio of the Aid flow from UN agencies (US$) of Egypt, Arab Rep. in 2003 to that in 2007?
Give a very brief answer. 9.56. What is the ratio of the Aid flow from UN agencies (US$) of Gambia, The in 2003 to that in 2007?
Ensure brevity in your answer.  0.66. What is the ratio of the Aid flow from UN agencies (US$) of Haiti in 2003 to that in 2007?
Provide a short and direct response. 3.26. What is the ratio of the Aid flow from UN agencies (US$) in Latin America(developing only) in 2004 to that in 2005?
Offer a very short reply. 0.92. What is the ratio of the Aid flow from UN agencies (US$) in Egypt, Arab Rep. in 2004 to that in 2005?
Your response must be concise. 0.95. What is the ratio of the Aid flow from UN agencies (US$) in Gambia, The in 2004 to that in 2005?
Give a very brief answer. 0.57. What is the ratio of the Aid flow from UN agencies (US$) in Haiti in 2004 to that in 2005?
Keep it short and to the point. 3.8. What is the ratio of the Aid flow from UN agencies (US$) of Latin America(developing only) in 2004 to that in 2006?
Your response must be concise. 1.08. What is the ratio of the Aid flow from UN agencies (US$) of Egypt, Arab Rep. in 2004 to that in 2006?
Offer a very short reply. 3.54. What is the ratio of the Aid flow from UN agencies (US$) of Gambia, The in 2004 to that in 2006?
Keep it short and to the point. 0.67. What is the ratio of the Aid flow from UN agencies (US$) of Haiti in 2004 to that in 2006?
Provide a short and direct response. 2.42. What is the ratio of the Aid flow from UN agencies (US$) of Latin America(developing only) in 2004 to that in 2007?
Provide a succinct answer. 1.19. What is the ratio of the Aid flow from UN agencies (US$) of Egypt, Arab Rep. in 2004 to that in 2007?
Your answer should be compact. 9.49. What is the ratio of the Aid flow from UN agencies (US$) of Gambia, The in 2004 to that in 2007?
Offer a terse response. 0.53. What is the ratio of the Aid flow from UN agencies (US$) in Haiti in 2004 to that in 2007?
Keep it short and to the point. 3.71. What is the ratio of the Aid flow from UN agencies (US$) in Latin America(developing only) in 2005 to that in 2006?
Keep it short and to the point. 1.16. What is the ratio of the Aid flow from UN agencies (US$) of Egypt, Arab Rep. in 2005 to that in 2006?
Your response must be concise. 3.72. What is the ratio of the Aid flow from UN agencies (US$) of Gambia, The in 2005 to that in 2006?
Provide a short and direct response. 1.18. What is the ratio of the Aid flow from UN agencies (US$) of Haiti in 2005 to that in 2006?
Your answer should be compact. 0.64. What is the ratio of the Aid flow from UN agencies (US$) in Latin America(developing only) in 2005 to that in 2007?
Your answer should be compact. 1.29. What is the ratio of the Aid flow from UN agencies (US$) in Egypt, Arab Rep. in 2005 to that in 2007?
Make the answer very short. 9.98. What is the ratio of the Aid flow from UN agencies (US$) of Gambia, The in 2005 to that in 2007?
Offer a very short reply. 0.93. What is the ratio of the Aid flow from UN agencies (US$) in Haiti in 2005 to that in 2007?
Offer a very short reply. 0.98. What is the ratio of the Aid flow from UN agencies (US$) in Latin America(developing only) in 2006 to that in 2007?
Provide a succinct answer. 1.11. What is the ratio of the Aid flow from UN agencies (US$) of Egypt, Arab Rep. in 2006 to that in 2007?
Your answer should be compact. 2.68. What is the ratio of the Aid flow from UN agencies (US$) of Gambia, The in 2006 to that in 2007?
Your response must be concise. 0.79. What is the ratio of the Aid flow from UN agencies (US$) of Haiti in 2006 to that in 2007?
Provide a short and direct response. 1.54. What is the difference between the highest and the second highest Aid flow from UN agencies (US$) of Latin America(developing only)?
Provide a short and direct response. 1.57e+06. What is the difference between the highest and the second highest Aid flow from UN agencies (US$) of Haiti?
Your answer should be compact. 8.30e+05. What is the difference between the highest and the lowest Aid flow from UN agencies (US$) of Latin America(developing only)?
Provide a short and direct response. 5.25e+06. What is the difference between the highest and the lowest Aid flow from UN agencies (US$) in Egypt, Arab Rep.?
Your response must be concise. 3.68e+06. What is the difference between the highest and the lowest Aid flow from UN agencies (US$) in Gambia, The?
Your answer should be compact. 9.10e+05. What is the difference between the highest and the lowest Aid flow from UN agencies (US$) in Haiti?
Your answer should be very brief. 5.06e+06. 